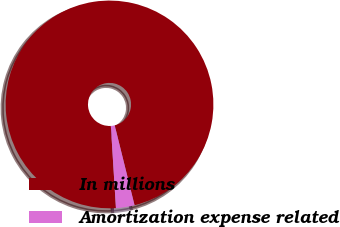<chart> <loc_0><loc_0><loc_500><loc_500><pie_chart><fcel>In millions<fcel>Amortization expense related<nl><fcel>97.11%<fcel>2.89%<nl></chart> 